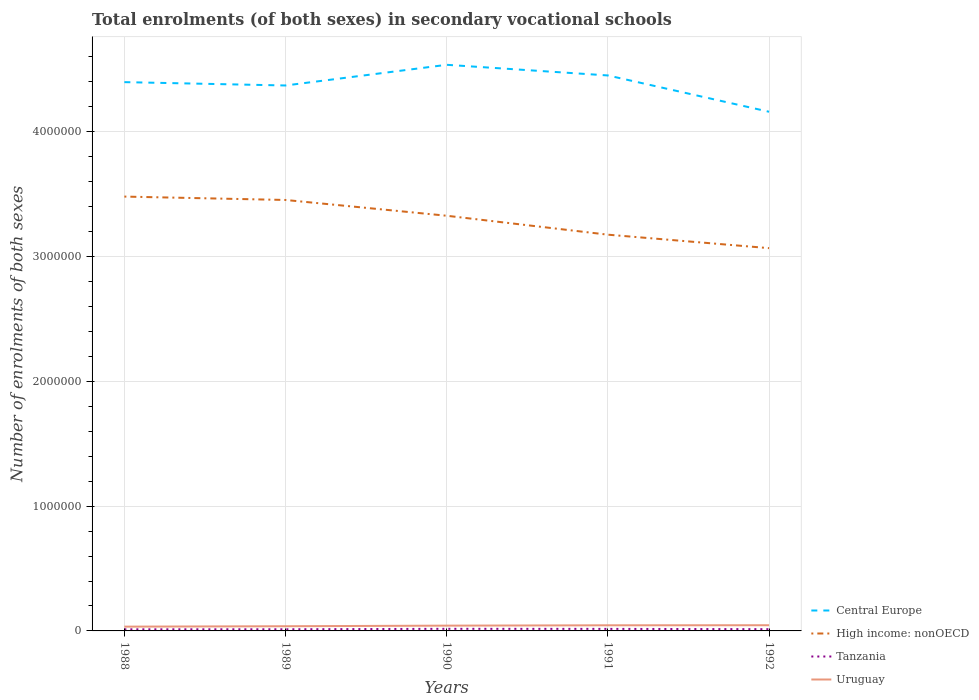How many different coloured lines are there?
Offer a very short reply. 4. Across all years, what is the maximum number of enrolments in secondary schools in Tanzania?
Provide a short and direct response. 1.28e+04. In which year was the number of enrolments in secondary schools in Uruguay maximum?
Make the answer very short. 1988. What is the total number of enrolments in secondary schools in Uruguay in the graph?
Offer a very short reply. -1.13e+04. What is the difference between the highest and the second highest number of enrolments in secondary schools in Uruguay?
Ensure brevity in your answer.  1.13e+04. Is the number of enrolments in secondary schools in Tanzania strictly greater than the number of enrolments in secondary schools in High income: nonOECD over the years?
Offer a very short reply. Yes. How many years are there in the graph?
Make the answer very short. 5. What is the difference between two consecutive major ticks on the Y-axis?
Ensure brevity in your answer.  1.00e+06. Are the values on the major ticks of Y-axis written in scientific E-notation?
Your answer should be very brief. No. Does the graph contain grids?
Give a very brief answer. Yes. How many legend labels are there?
Your response must be concise. 4. What is the title of the graph?
Offer a terse response. Total enrolments (of both sexes) in secondary vocational schools. Does "Turkmenistan" appear as one of the legend labels in the graph?
Give a very brief answer. No. What is the label or title of the Y-axis?
Make the answer very short. Number of enrolments of both sexes. What is the Number of enrolments of both sexes of Central Europe in 1988?
Provide a succinct answer. 4.40e+06. What is the Number of enrolments of both sexes of High income: nonOECD in 1988?
Offer a very short reply. 3.48e+06. What is the Number of enrolments of both sexes of Tanzania in 1988?
Provide a succinct answer. 1.28e+04. What is the Number of enrolments of both sexes of Uruguay in 1988?
Your answer should be compact. 3.43e+04. What is the Number of enrolments of both sexes of Central Europe in 1989?
Give a very brief answer. 4.37e+06. What is the Number of enrolments of both sexes of High income: nonOECD in 1989?
Make the answer very short. 3.45e+06. What is the Number of enrolments of both sexes in Tanzania in 1989?
Ensure brevity in your answer.  1.33e+04. What is the Number of enrolments of both sexes of Uruguay in 1989?
Ensure brevity in your answer.  3.75e+04. What is the Number of enrolments of both sexes in Central Europe in 1990?
Offer a terse response. 4.54e+06. What is the Number of enrolments of both sexes in High income: nonOECD in 1990?
Your answer should be very brief. 3.33e+06. What is the Number of enrolments of both sexes in Tanzania in 1990?
Your response must be concise. 1.68e+04. What is the Number of enrolments of both sexes of Uruguay in 1990?
Give a very brief answer. 4.24e+04. What is the Number of enrolments of both sexes in Central Europe in 1991?
Your answer should be compact. 4.45e+06. What is the Number of enrolments of both sexes of High income: nonOECD in 1991?
Your answer should be very brief. 3.18e+06. What is the Number of enrolments of both sexes in Tanzania in 1991?
Ensure brevity in your answer.  1.63e+04. What is the Number of enrolments of both sexes in Uruguay in 1991?
Make the answer very short. 4.50e+04. What is the Number of enrolments of both sexes in Central Europe in 1992?
Provide a short and direct response. 4.16e+06. What is the Number of enrolments of both sexes in High income: nonOECD in 1992?
Your answer should be compact. 3.07e+06. What is the Number of enrolments of both sexes in Tanzania in 1992?
Your response must be concise. 1.41e+04. What is the Number of enrolments of both sexes of Uruguay in 1992?
Your response must be concise. 4.56e+04. Across all years, what is the maximum Number of enrolments of both sexes in Central Europe?
Provide a short and direct response. 4.54e+06. Across all years, what is the maximum Number of enrolments of both sexes in High income: nonOECD?
Offer a very short reply. 3.48e+06. Across all years, what is the maximum Number of enrolments of both sexes in Tanzania?
Make the answer very short. 1.68e+04. Across all years, what is the maximum Number of enrolments of both sexes in Uruguay?
Make the answer very short. 4.56e+04. Across all years, what is the minimum Number of enrolments of both sexes in Central Europe?
Your response must be concise. 4.16e+06. Across all years, what is the minimum Number of enrolments of both sexes in High income: nonOECD?
Your response must be concise. 3.07e+06. Across all years, what is the minimum Number of enrolments of both sexes of Tanzania?
Your response must be concise. 1.28e+04. Across all years, what is the minimum Number of enrolments of both sexes of Uruguay?
Provide a succinct answer. 3.43e+04. What is the total Number of enrolments of both sexes in Central Europe in the graph?
Make the answer very short. 2.19e+07. What is the total Number of enrolments of both sexes in High income: nonOECD in the graph?
Your answer should be compact. 1.65e+07. What is the total Number of enrolments of both sexes of Tanzania in the graph?
Provide a succinct answer. 7.33e+04. What is the total Number of enrolments of both sexes in Uruguay in the graph?
Offer a terse response. 2.05e+05. What is the difference between the Number of enrolments of both sexes of Central Europe in 1988 and that in 1989?
Make the answer very short. 2.68e+04. What is the difference between the Number of enrolments of both sexes in High income: nonOECD in 1988 and that in 1989?
Give a very brief answer. 2.72e+04. What is the difference between the Number of enrolments of both sexes of Tanzania in 1988 and that in 1989?
Offer a very short reply. -431. What is the difference between the Number of enrolments of both sexes of Uruguay in 1988 and that in 1989?
Your answer should be very brief. -3229. What is the difference between the Number of enrolments of both sexes in Central Europe in 1988 and that in 1990?
Offer a very short reply. -1.39e+05. What is the difference between the Number of enrolments of both sexes in High income: nonOECD in 1988 and that in 1990?
Offer a very short reply. 1.54e+05. What is the difference between the Number of enrolments of both sexes of Tanzania in 1988 and that in 1990?
Your answer should be compact. -4018. What is the difference between the Number of enrolments of both sexes in Uruguay in 1988 and that in 1990?
Provide a short and direct response. -8051. What is the difference between the Number of enrolments of both sexes in Central Europe in 1988 and that in 1991?
Keep it short and to the point. -5.36e+04. What is the difference between the Number of enrolments of both sexes in High income: nonOECD in 1988 and that in 1991?
Offer a terse response. 3.05e+05. What is the difference between the Number of enrolments of both sexes in Tanzania in 1988 and that in 1991?
Your response must be concise. -3465. What is the difference between the Number of enrolments of both sexes in Uruguay in 1988 and that in 1991?
Keep it short and to the point. -1.07e+04. What is the difference between the Number of enrolments of both sexes in Central Europe in 1988 and that in 1992?
Keep it short and to the point. 2.37e+05. What is the difference between the Number of enrolments of both sexes of High income: nonOECD in 1988 and that in 1992?
Give a very brief answer. 4.13e+05. What is the difference between the Number of enrolments of both sexes in Tanzania in 1988 and that in 1992?
Give a very brief answer. -1219. What is the difference between the Number of enrolments of both sexes of Uruguay in 1988 and that in 1992?
Give a very brief answer. -1.13e+04. What is the difference between the Number of enrolments of both sexes in Central Europe in 1989 and that in 1990?
Make the answer very short. -1.66e+05. What is the difference between the Number of enrolments of both sexes of High income: nonOECD in 1989 and that in 1990?
Keep it short and to the point. 1.26e+05. What is the difference between the Number of enrolments of both sexes in Tanzania in 1989 and that in 1990?
Give a very brief answer. -3587. What is the difference between the Number of enrolments of both sexes in Uruguay in 1989 and that in 1990?
Your answer should be very brief. -4822. What is the difference between the Number of enrolments of both sexes of Central Europe in 1989 and that in 1991?
Make the answer very short. -8.04e+04. What is the difference between the Number of enrolments of both sexes of High income: nonOECD in 1989 and that in 1991?
Keep it short and to the point. 2.78e+05. What is the difference between the Number of enrolments of both sexes of Tanzania in 1989 and that in 1991?
Your answer should be compact. -3034. What is the difference between the Number of enrolments of both sexes in Uruguay in 1989 and that in 1991?
Ensure brevity in your answer.  -7499. What is the difference between the Number of enrolments of both sexes in Central Europe in 1989 and that in 1992?
Ensure brevity in your answer.  2.11e+05. What is the difference between the Number of enrolments of both sexes of High income: nonOECD in 1989 and that in 1992?
Keep it short and to the point. 3.86e+05. What is the difference between the Number of enrolments of both sexes in Tanzania in 1989 and that in 1992?
Offer a terse response. -788. What is the difference between the Number of enrolments of both sexes in Uruguay in 1989 and that in 1992?
Keep it short and to the point. -8034. What is the difference between the Number of enrolments of both sexes in Central Europe in 1990 and that in 1991?
Make the answer very short. 8.53e+04. What is the difference between the Number of enrolments of both sexes of High income: nonOECD in 1990 and that in 1991?
Offer a very short reply. 1.52e+05. What is the difference between the Number of enrolments of both sexes of Tanzania in 1990 and that in 1991?
Make the answer very short. 553. What is the difference between the Number of enrolments of both sexes in Uruguay in 1990 and that in 1991?
Offer a very short reply. -2677. What is the difference between the Number of enrolments of both sexes of Central Europe in 1990 and that in 1992?
Provide a succinct answer. 3.76e+05. What is the difference between the Number of enrolments of both sexes in High income: nonOECD in 1990 and that in 1992?
Your answer should be very brief. 2.60e+05. What is the difference between the Number of enrolments of both sexes of Tanzania in 1990 and that in 1992?
Give a very brief answer. 2799. What is the difference between the Number of enrolments of both sexes of Uruguay in 1990 and that in 1992?
Keep it short and to the point. -3212. What is the difference between the Number of enrolments of both sexes in Central Europe in 1991 and that in 1992?
Your answer should be very brief. 2.91e+05. What is the difference between the Number of enrolments of both sexes in High income: nonOECD in 1991 and that in 1992?
Give a very brief answer. 1.08e+05. What is the difference between the Number of enrolments of both sexes in Tanzania in 1991 and that in 1992?
Your response must be concise. 2246. What is the difference between the Number of enrolments of both sexes in Uruguay in 1991 and that in 1992?
Provide a short and direct response. -535. What is the difference between the Number of enrolments of both sexes in Central Europe in 1988 and the Number of enrolments of both sexes in High income: nonOECD in 1989?
Make the answer very short. 9.44e+05. What is the difference between the Number of enrolments of both sexes of Central Europe in 1988 and the Number of enrolments of both sexes of Tanzania in 1989?
Make the answer very short. 4.38e+06. What is the difference between the Number of enrolments of both sexes in Central Europe in 1988 and the Number of enrolments of both sexes in Uruguay in 1989?
Your answer should be very brief. 4.36e+06. What is the difference between the Number of enrolments of both sexes in High income: nonOECD in 1988 and the Number of enrolments of both sexes in Tanzania in 1989?
Offer a terse response. 3.47e+06. What is the difference between the Number of enrolments of both sexes of High income: nonOECD in 1988 and the Number of enrolments of both sexes of Uruguay in 1989?
Give a very brief answer. 3.44e+06. What is the difference between the Number of enrolments of both sexes of Tanzania in 1988 and the Number of enrolments of both sexes of Uruguay in 1989?
Offer a terse response. -2.47e+04. What is the difference between the Number of enrolments of both sexes in Central Europe in 1988 and the Number of enrolments of both sexes in High income: nonOECD in 1990?
Provide a succinct answer. 1.07e+06. What is the difference between the Number of enrolments of both sexes in Central Europe in 1988 and the Number of enrolments of both sexes in Tanzania in 1990?
Offer a terse response. 4.38e+06. What is the difference between the Number of enrolments of both sexes in Central Europe in 1988 and the Number of enrolments of both sexes in Uruguay in 1990?
Offer a very short reply. 4.36e+06. What is the difference between the Number of enrolments of both sexes in High income: nonOECD in 1988 and the Number of enrolments of both sexes in Tanzania in 1990?
Keep it short and to the point. 3.46e+06. What is the difference between the Number of enrolments of both sexes of High income: nonOECD in 1988 and the Number of enrolments of both sexes of Uruguay in 1990?
Offer a very short reply. 3.44e+06. What is the difference between the Number of enrolments of both sexes of Tanzania in 1988 and the Number of enrolments of both sexes of Uruguay in 1990?
Your answer should be compact. -2.95e+04. What is the difference between the Number of enrolments of both sexes in Central Europe in 1988 and the Number of enrolments of both sexes in High income: nonOECD in 1991?
Give a very brief answer. 1.22e+06. What is the difference between the Number of enrolments of both sexes in Central Europe in 1988 and the Number of enrolments of both sexes in Tanzania in 1991?
Provide a short and direct response. 4.38e+06. What is the difference between the Number of enrolments of both sexes of Central Europe in 1988 and the Number of enrolments of both sexes of Uruguay in 1991?
Your answer should be very brief. 4.35e+06. What is the difference between the Number of enrolments of both sexes of High income: nonOECD in 1988 and the Number of enrolments of both sexes of Tanzania in 1991?
Offer a terse response. 3.46e+06. What is the difference between the Number of enrolments of both sexes of High income: nonOECD in 1988 and the Number of enrolments of both sexes of Uruguay in 1991?
Your answer should be very brief. 3.44e+06. What is the difference between the Number of enrolments of both sexes in Tanzania in 1988 and the Number of enrolments of both sexes in Uruguay in 1991?
Provide a succinct answer. -3.22e+04. What is the difference between the Number of enrolments of both sexes of Central Europe in 1988 and the Number of enrolments of both sexes of High income: nonOECD in 1992?
Give a very brief answer. 1.33e+06. What is the difference between the Number of enrolments of both sexes of Central Europe in 1988 and the Number of enrolments of both sexes of Tanzania in 1992?
Keep it short and to the point. 4.38e+06. What is the difference between the Number of enrolments of both sexes of Central Europe in 1988 and the Number of enrolments of both sexes of Uruguay in 1992?
Provide a short and direct response. 4.35e+06. What is the difference between the Number of enrolments of both sexes in High income: nonOECD in 1988 and the Number of enrolments of both sexes in Tanzania in 1992?
Give a very brief answer. 3.47e+06. What is the difference between the Number of enrolments of both sexes in High income: nonOECD in 1988 and the Number of enrolments of both sexes in Uruguay in 1992?
Your response must be concise. 3.44e+06. What is the difference between the Number of enrolments of both sexes of Tanzania in 1988 and the Number of enrolments of both sexes of Uruguay in 1992?
Offer a terse response. -3.27e+04. What is the difference between the Number of enrolments of both sexes of Central Europe in 1989 and the Number of enrolments of both sexes of High income: nonOECD in 1990?
Offer a terse response. 1.04e+06. What is the difference between the Number of enrolments of both sexes of Central Europe in 1989 and the Number of enrolments of both sexes of Tanzania in 1990?
Offer a very short reply. 4.35e+06. What is the difference between the Number of enrolments of both sexes of Central Europe in 1989 and the Number of enrolments of both sexes of Uruguay in 1990?
Give a very brief answer. 4.33e+06. What is the difference between the Number of enrolments of both sexes in High income: nonOECD in 1989 and the Number of enrolments of both sexes in Tanzania in 1990?
Ensure brevity in your answer.  3.44e+06. What is the difference between the Number of enrolments of both sexes in High income: nonOECD in 1989 and the Number of enrolments of both sexes in Uruguay in 1990?
Provide a succinct answer. 3.41e+06. What is the difference between the Number of enrolments of both sexes in Tanzania in 1989 and the Number of enrolments of both sexes in Uruguay in 1990?
Your answer should be very brief. -2.91e+04. What is the difference between the Number of enrolments of both sexes of Central Europe in 1989 and the Number of enrolments of both sexes of High income: nonOECD in 1991?
Keep it short and to the point. 1.20e+06. What is the difference between the Number of enrolments of both sexes of Central Europe in 1989 and the Number of enrolments of both sexes of Tanzania in 1991?
Your answer should be compact. 4.35e+06. What is the difference between the Number of enrolments of both sexes in Central Europe in 1989 and the Number of enrolments of both sexes in Uruguay in 1991?
Your answer should be very brief. 4.33e+06. What is the difference between the Number of enrolments of both sexes of High income: nonOECD in 1989 and the Number of enrolments of both sexes of Tanzania in 1991?
Your answer should be compact. 3.44e+06. What is the difference between the Number of enrolments of both sexes in High income: nonOECD in 1989 and the Number of enrolments of both sexes in Uruguay in 1991?
Make the answer very short. 3.41e+06. What is the difference between the Number of enrolments of both sexes in Tanzania in 1989 and the Number of enrolments of both sexes in Uruguay in 1991?
Offer a very short reply. -3.18e+04. What is the difference between the Number of enrolments of both sexes in Central Europe in 1989 and the Number of enrolments of both sexes in High income: nonOECD in 1992?
Keep it short and to the point. 1.30e+06. What is the difference between the Number of enrolments of both sexes in Central Europe in 1989 and the Number of enrolments of both sexes in Tanzania in 1992?
Your answer should be very brief. 4.36e+06. What is the difference between the Number of enrolments of both sexes in Central Europe in 1989 and the Number of enrolments of both sexes in Uruguay in 1992?
Keep it short and to the point. 4.33e+06. What is the difference between the Number of enrolments of both sexes in High income: nonOECD in 1989 and the Number of enrolments of both sexes in Tanzania in 1992?
Your answer should be very brief. 3.44e+06. What is the difference between the Number of enrolments of both sexes of High income: nonOECD in 1989 and the Number of enrolments of both sexes of Uruguay in 1992?
Make the answer very short. 3.41e+06. What is the difference between the Number of enrolments of both sexes in Tanzania in 1989 and the Number of enrolments of both sexes in Uruguay in 1992?
Provide a succinct answer. -3.23e+04. What is the difference between the Number of enrolments of both sexes in Central Europe in 1990 and the Number of enrolments of both sexes in High income: nonOECD in 1991?
Your answer should be compact. 1.36e+06. What is the difference between the Number of enrolments of both sexes in Central Europe in 1990 and the Number of enrolments of both sexes in Tanzania in 1991?
Provide a short and direct response. 4.52e+06. What is the difference between the Number of enrolments of both sexes in Central Europe in 1990 and the Number of enrolments of both sexes in Uruguay in 1991?
Give a very brief answer. 4.49e+06. What is the difference between the Number of enrolments of both sexes in High income: nonOECD in 1990 and the Number of enrolments of both sexes in Tanzania in 1991?
Provide a short and direct response. 3.31e+06. What is the difference between the Number of enrolments of both sexes of High income: nonOECD in 1990 and the Number of enrolments of both sexes of Uruguay in 1991?
Your answer should be very brief. 3.28e+06. What is the difference between the Number of enrolments of both sexes of Tanzania in 1990 and the Number of enrolments of both sexes of Uruguay in 1991?
Provide a short and direct response. -2.82e+04. What is the difference between the Number of enrolments of both sexes in Central Europe in 1990 and the Number of enrolments of both sexes in High income: nonOECD in 1992?
Offer a terse response. 1.47e+06. What is the difference between the Number of enrolments of both sexes of Central Europe in 1990 and the Number of enrolments of both sexes of Tanzania in 1992?
Make the answer very short. 4.52e+06. What is the difference between the Number of enrolments of both sexes in Central Europe in 1990 and the Number of enrolments of both sexes in Uruguay in 1992?
Your response must be concise. 4.49e+06. What is the difference between the Number of enrolments of both sexes of High income: nonOECD in 1990 and the Number of enrolments of both sexes of Tanzania in 1992?
Ensure brevity in your answer.  3.31e+06. What is the difference between the Number of enrolments of both sexes in High income: nonOECD in 1990 and the Number of enrolments of both sexes in Uruguay in 1992?
Your answer should be compact. 3.28e+06. What is the difference between the Number of enrolments of both sexes of Tanzania in 1990 and the Number of enrolments of both sexes of Uruguay in 1992?
Keep it short and to the point. -2.87e+04. What is the difference between the Number of enrolments of both sexes of Central Europe in 1991 and the Number of enrolments of both sexes of High income: nonOECD in 1992?
Your answer should be compact. 1.38e+06. What is the difference between the Number of enrolments of both sexes in Central Europe in 1991 and the Number of enrolments of both sexes in Tanzania in 1992?
Offer a very short reply. 4.44e+06. What is the difference between the Number of enrolments of both sexes in Central Europe in 1991 and the Number of enrolments of both sexes in Uruguay in 1992?
Your response must be concise. 4.41e+06. What is the difference between the Number of enrolments of both sexes of High income: nonOECD in 1991 and the Number of enrolments of both sexes of Tanzania in 1992?
Your response must be concise. 3.16e+06. What is the difference between the Number of enrolments of both sexes in High income: nonOECD in 1991 and the Number of enrolments of both sexes in Uruguay in 1992?
Keep it short and to the point. 3.13e+06. What is the difference between the Number of enrolments of both sexes in Tanzania in 1991 and the Number of enrolments of both sexes in Uruguay in 1992?
Your answer should be compact. -2.93e+04. What is the average Number of enrolments of both sexes in Central Europe per year?
Keep it short and to the point. 4.38e+06. What is the average Number of enrolments of both sexes in High income: nonOECD per year?
Your answer should be very brief. 3.30e+06. What is the average Number of enrolments of both sexes of Tanzania per year?
Provide a succinct answer. 1.47e+04. What is the average Number of enrolments of both sexes in Uruguay per year?
Provide a succinct answer. 4.10e+04. In the year 1988, what is the difference between the Number of enrolments of both sexes of Central Europe and Number of enrolments of both sexes of High income: nonOECD?
Provide a short and direct response. 9.17e+05. In the year 1988, what is the difference between the Number of enrolments of both sexes in Central Europe and Number of enrolments of both sexes in Tanzania?
Offer a very short reply. 4.39e+06. In the year 1988, what is the difference between the Number of enrolments of both sexes of Central Europe and Number of enrolments of both sexes of Uruguay?
Your answer should be compact. 4.36e+06. In the year 1988, what is the difference between the Number of enrolments of both sexes of High income: nonOECD and Number of enrolments of both sexes of Tanzania?
Offer a very short reply. 3.47e+06. In the year 1988, what is the difference between the Number of enrolments of both sexes of High income: nonOECD and Number of enrolments of both sexes of Uruguay?
Provide a short and direct response. 3.45e+06. In the year 1988, what is the difference between the Number of enrolments of both sexes in Tanzania and Number of enrolments of both sexes in Uruguay?
Give a very brief answer. -2.15e+04. In the year 1989, what is the difference between the Number of enrolments of both sexes of Central Europe and Number of enrolments of both sexes of High income: nonOECD?
Provide a short and direct response. 9.18e+05. In the year 1989, what is the difference between the Number of enrolments of both sexes in Central Europe and Number of enrolments of both sexes in Tanzania?
Your response must be concise. 4.36e+06. In the year 1989, what is the difference between the Number of enrolments of both sexes in Central Europe and Number of enrolments of both sexes in Uruguay?
Your response must be concise. 4.33e+06. In the year 1989, what is the difference between the Number of enrolments of both sexes in High income: nonOECD and Number of enrolments of both sexes in Tanzania?
Ensure brevity in your answer.  3.44e+06. In the year 1989, what is the difference between the Number of enrolments of both sexes of High income: nonOECD and Number of enrolments of both sexes of Uruguay?
Make the answer very short. 3.42e+06. In the year 1989, what is the difference between the Number of enrolments of both sexes of Tanzania and Number of enrolments of both sexes of Uruguay?
Give a very brief answer. -2.43e+04. In the year 1990, what is the difference between the Number of enrolments of both sexes in Central Europe and Number of enrolments of both sexes in High income: nonOECD?
Make the answer very short. 1.21e+06. In the year 1990, what is the difference between the Number of enrolments of both sexes of Central Europe and Number of enrolments of both sexes of Tanzania?
Keep it short and to the point. 4.52e+06. In the year 1990, what is the difference between the Number of enrolments of both sexes of Central Europe and Number of enrolments of both sexes of Uruguay?
Your response must be concise. 4.49e+06. In the year 1990, what is the difference between the Number of enrolments of both sexes of High income: nonOECD and Number of enrolments of both sexes of Tanzania?
Give a very brief answer. 3.31e+06. In the year 1990, what is the difference between the Number of enrolments of both sexes in High income: nonOECD and Number of enrolments of both sexes in Uruguay?
Offer a terse response. 3.28e+06. In the year 1990, what is the difference between the Number of enrolments of both sexes in Tanzania and Number of enrolments of both sexes in Uruguay?
Provide a succinct answer. -2.55e+04. In the year 1991, what is the difference between the Number of enrolments of both sexes in Central Europe and Number of enrolments of both sexes in High income: nonOECD?
Offer a very short reply. 1.28e+06. In the year 1991, what is the difference between the Number of enrolments of both sexes of Central Europe and Number of enrolments of both sexes of Tanzania?
Make the answer very short. 4.44e+06. In the year 1991, what is the difference between the Number of enrolments of both sexes of Central Europe and Number of enrolments of both sexes of Uruguay?
Provide a succinct answer. 4.41e+06. In the year 1991, what is the difference between the Number of enrolments of both sexes in High income: nonOECD and Number of enrolments of both sexes in Tanzania?
Ensure brevity in your answer.  3.16e+06. In the year 1991, what is the difference between the Number of enrolments of both sexes in High income: nonOECD and Number of enrolments of both sexes in Uruguay?
Your response must be concise. 3.13e+06. In the year 1991, what is the difference between the Number of enrolments of both sexes in Tanzania and Number of enrolments of both sexes in Uruguay?
Give a very brief answer. -2.87e+04. In the year 1992, what is the difference between the Number of enrolments of both sexes of Central Europe and Number of enrolments of both sexes of High income: nonOECD?
Give a very brief answer. 1.09e+06. In the year 1992, what is the difference between the Number of enrolments of both sexes of Central Europe and Number of enrolments of both sexes of Tanzania?
Offer a terse response. 4.15e+06. In the year 1992, what is the difference between the Number of enrolments of both sexes in Central Europe and Number of enrolments of both sexes in Uruguay?
Provide a short and direct response. 4.12e+06. In the year 1992, what is the difference between the Number of enrolments of both sexes of High income: nonOECD and Number of enrolments of both sexes of Tanzania?
Keep it short and to the point. 3.05e+06. In the year 1992, what is the difference between the Number of enrolments of both sexes of High income: nonOECD and Number of enrolments of both sexes of Uruguay?
Keep it short and to the point. 3.02e+06. In the year 1992, what is the difference between the Number of enrolments of both sexes in Tanzania and Number of enrolments of both sexes in Uruguay?
Keep it short and to the point. -3.15e+04. What is the ratio of the Number of enrolments of both sexes of Central Europe in 1988 to that in 1989?
Provide a short and direct response. 1.01. What is the ratio of the Number of enrolments of both sexes in High income: nonOECD in 1988 to that in 1989?
Give a very brief answer. 1.01. What is the ratio of the Number of enrolments of both sexes in Tanzania in 1988 to that in 1989?
Provide a succinct answer. 0.97. What is the ratio of the Number of enrolments of both sexes of Uruguay in 1988 to that in 1989?
Your answer should be compact. 0.91. What is the ratio of the Number of enrolments of both sexes of Central Europe in 1988 to that in 1990?
Your response must be concise. 0.97. What is the ratio of the Number of enrolments of both sexes in High income: nonOECD in 1988 to that in 1990?
Provide a short and direct response. 1.05. What is the ratio of the Number of enrolments of both sexes in Tanzania in 1988 to that in 1990?
Give a very brief answer. 0.76. What is the ratio of the Number of enrolments of both sexes of Uruguay in 1988 to that in 1990?
Provide a short and direct response. 0.81. What is the ratio of the Number of enrolments of both sexes of High income: nonOECD in 1988 to that in 1991?
Offer a very short reply. 1.1. What is the ratio of the Number of enrolments of both sexes of Tanzania in 1988 to that in 1991?
Your response must be concise. 0.79. What is the ratio of the Number of enrolments of both sexes of Uruguay in 1988 to that in 1991?
Give a very brief answer. 0.76. What is the ratio of the Number of enrolments of both sexes in Central Europe in 1988 to that in 1992?
Provide a short and direct response. 1.06. What is the ratio of the Number of enrolments of both sexes in High income: nonOECD in 1988 to that in 1992?
Your response must be concise. 1.13. What is the ratio of the Number of enrolments of both sexes of Tanzania in 1988 to that in 1992?
Keep it short and to the point. 0.91. What is the ratio of the Number of enrolments of both sexes of Uruguay in 1988 to that in 1992?
Offer a very short reply. 0.75. What is the ratio of the Number of enrolments of both sexes in Central Europe in 1989 to that in 1990?
Ensure brevity in your answer.  0.96. What is the ratio of the Number of enrolments of both sexes of High income: nonOECD in 1989 to that in 1990?
Ensure brevity in your answer.  1.04. What is the ratio of the Number of enrolments of both sexes in Tanzania in 1989 to that in 1990?
Your answer should be very brief. 0.79. What is the ratio of the Number of enrolments of both sexes in Uruguay in 1989 to that in 1990?
Your response must be concise. 0.89. What is the ratio of the Number of enrolments of both sexes of Central Europe in 1989 to that in 1991?
Keep it short and to the point. 0.98. What is the ratio of the Number of enrolments of both sexes in High income: nonOECD in 1989 to that in 1991?
Offer a very short reply. 1.09. What is the ratio of the Number of enrolments of both sexes of Tanzania in 1989 to that in 1991?
Keep it short and to the point. 0.81. What is the ratio of the Number of enrolments of both sexes in Uruguay in 1989 to that in 1991?
Make the answer very short. 0.83. What is the ratio of the Number of enrolments of both sexes of Central Europe in 1989 to that in 1992?
Provide a short and direct response. 1.05. What is the ratio of the Number of enrolments of both sexes of High income: nonOECD in 1989 to that in 1992?
Offer a terse response. 1.13. What is the ratio of the Number of enrolments of both sexes in Tanzania in 1989 to that in 1992?
Your answer should be very brief. 0.94. What is the ratio of the Number of enrolments of both sexes in Uruguay in 1989 to that in 1992?
Your answer should be compact. 0.82. What is the ratio of the Number of enrolments of both sexes in Central Europe in 1990 to that in 1991?
Your answer should be very brief. 1.02. What is the ratio of the Number of enrolments of both sexes of High income: nonOECD in 1990 to that in 1991?
Make the answer very short. 1.05. What is the ratio of the Number of enrolments of both sexes of Tanzania in 1990 to that in 1991?
Your answer should be compact. 1.03. What is the ratio of the Number of enrolments of both sexes of Uruguay in 1990 to that in 1991?
Ensure brevity in your answer.  0.94. What is the ratio of the Number of enrolments of both sexes in Central Europe in 1990 to that in 1992?
Ensure brevity in your answer.  1.09. What is the ratio of the Number of enrolments of both sexes in High income: nonOECD in 1990 to that in 1992?
Provide a succinct answer. 1.08. What is the ratio of the Number of enrolments of both sexes in Tanzania in 1990 to that in 1992?
Offer a terse response. 1.2. What is the ratio of the Number of enrolments of both sexes of Uruguay in 1990 to that in 1992?
Offer a terse response. 0.93. What is the ratio of the Number of enrolments of both sexes of Central Europe in 1991 to that in 1992?
Provide a succinct answer. 1.07. What is the ratio of the Number of enrolments of both sexes in High income: nonOECD in 1991 to that in 1992?
Ensure brevity in your answer.  1.04. What is the ratio of the Number of enrolments of both sexes of Tanzania in 1991 to that in 1992?
Offer a very short reply. 1.16. What is the ratio of the Number of enrolments of both sexes of Uruguay in 1991 to that in 1992?
Your response must be concise. 0.99. What is the difference between the highest and the second highest Number of enrolments of both sexes in Central Europe?
Offer a terse response. 8.53e+04. What is the difference between the highest and the second highest Number of enrolments of both sexes of High income: nonOECD?
Make the answer very short. 2.72e+04. What is the difference between the highest and the second highest Number of enrolments of both sexes in Tanzania?
Provide a short and direct response. 553. What is the difference between the highest and the second highest Number of enrolments of both sexes in Uruguay?
Offer a terse response. 535. What is the difference between the highest and the lowest Number of enrolments of both sexes of Central Europe?
Give a very brief answer. 3.76e+05. What is the difference between the highest and the lowest Number of enrolments of both sexes of High income: nonOECD?
Your answer should be compact. 4.13e+05. What is the difference between the highest and the lowest Number of enrolments of both sexes in Tanzania?
Your response must be concise. 4018. What is the difference between the highest and the lowest Number of enrolments of both sexes in Uruguay?
Your answer should be very brief. 1.13e+04. 